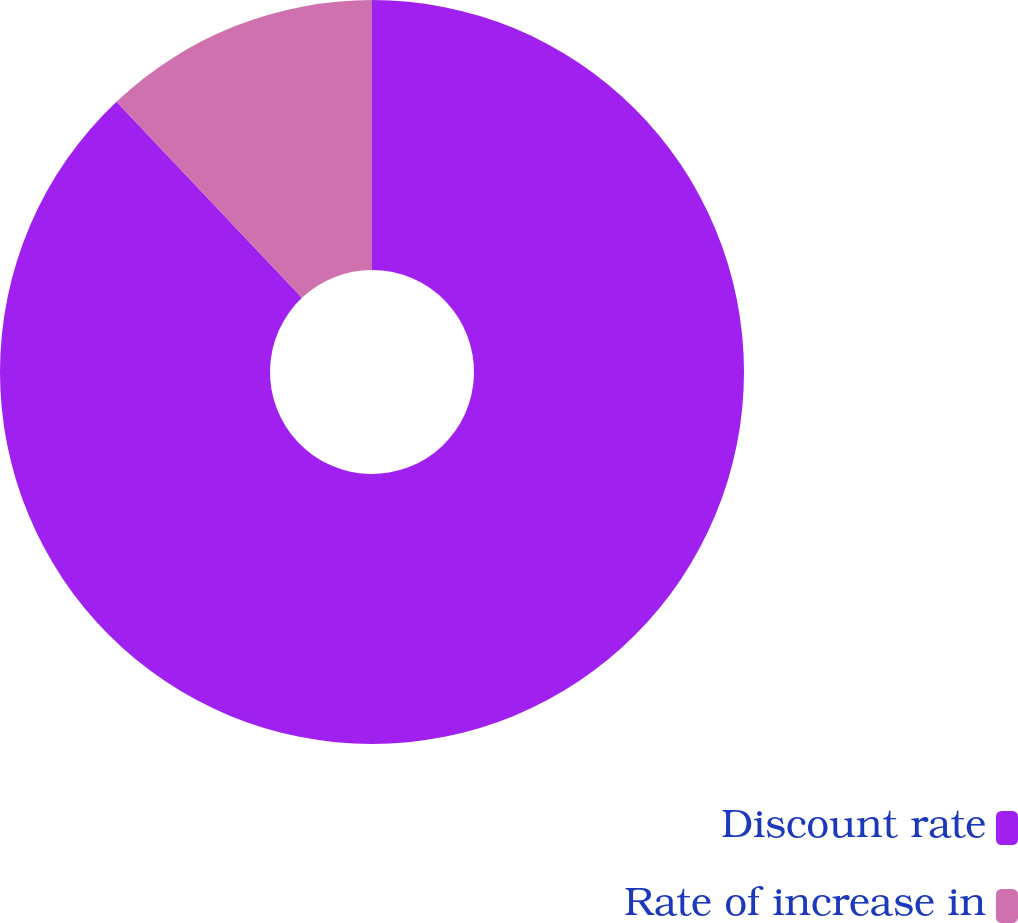<chart> <loc_0><loc_0><loc_500><loc_500><pie_chart><fcel>Discount rate<fcel>Rate of increase in<nl><fcel>87.95%<fcel>12.05%<nl></chart> 